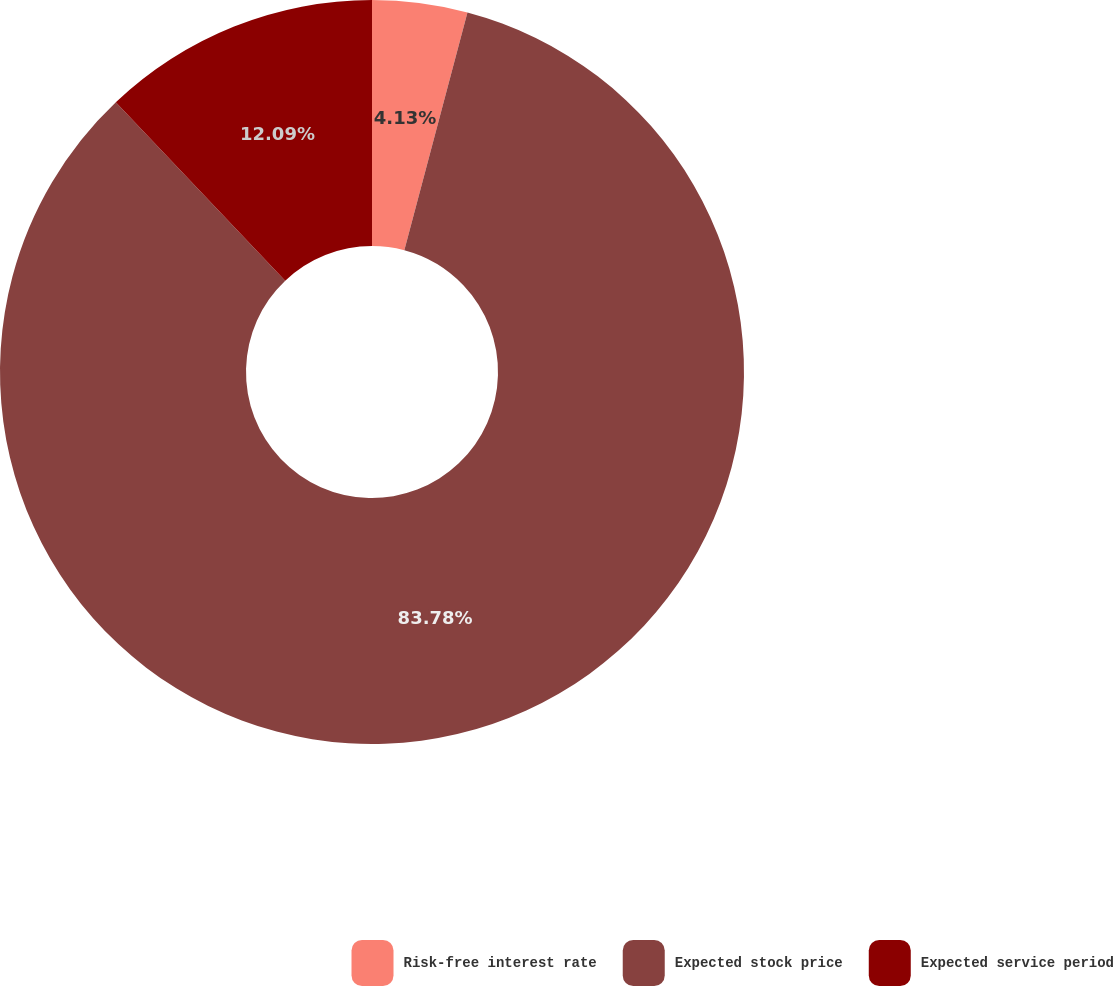Convert chart. <chart><loc_0><loc_0><loc_500><loc_500><pie_chart><fcel>Risk-free interest rate<fcel>Expected stock price<fcel>Expected service period<nl><fcel>4.13%<fcel>83.78%<fcel>12.09%<nl></chart> 